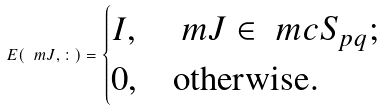<formula> <loc_0><loc_0><loc_500><loc_500>E ( \ m J , \colon ) = \begin{cases} I , & \ m J \in \ m c { S } _ { p q } ; \\ 0 , & \text {otherwise} . \end{cases}</formula> 